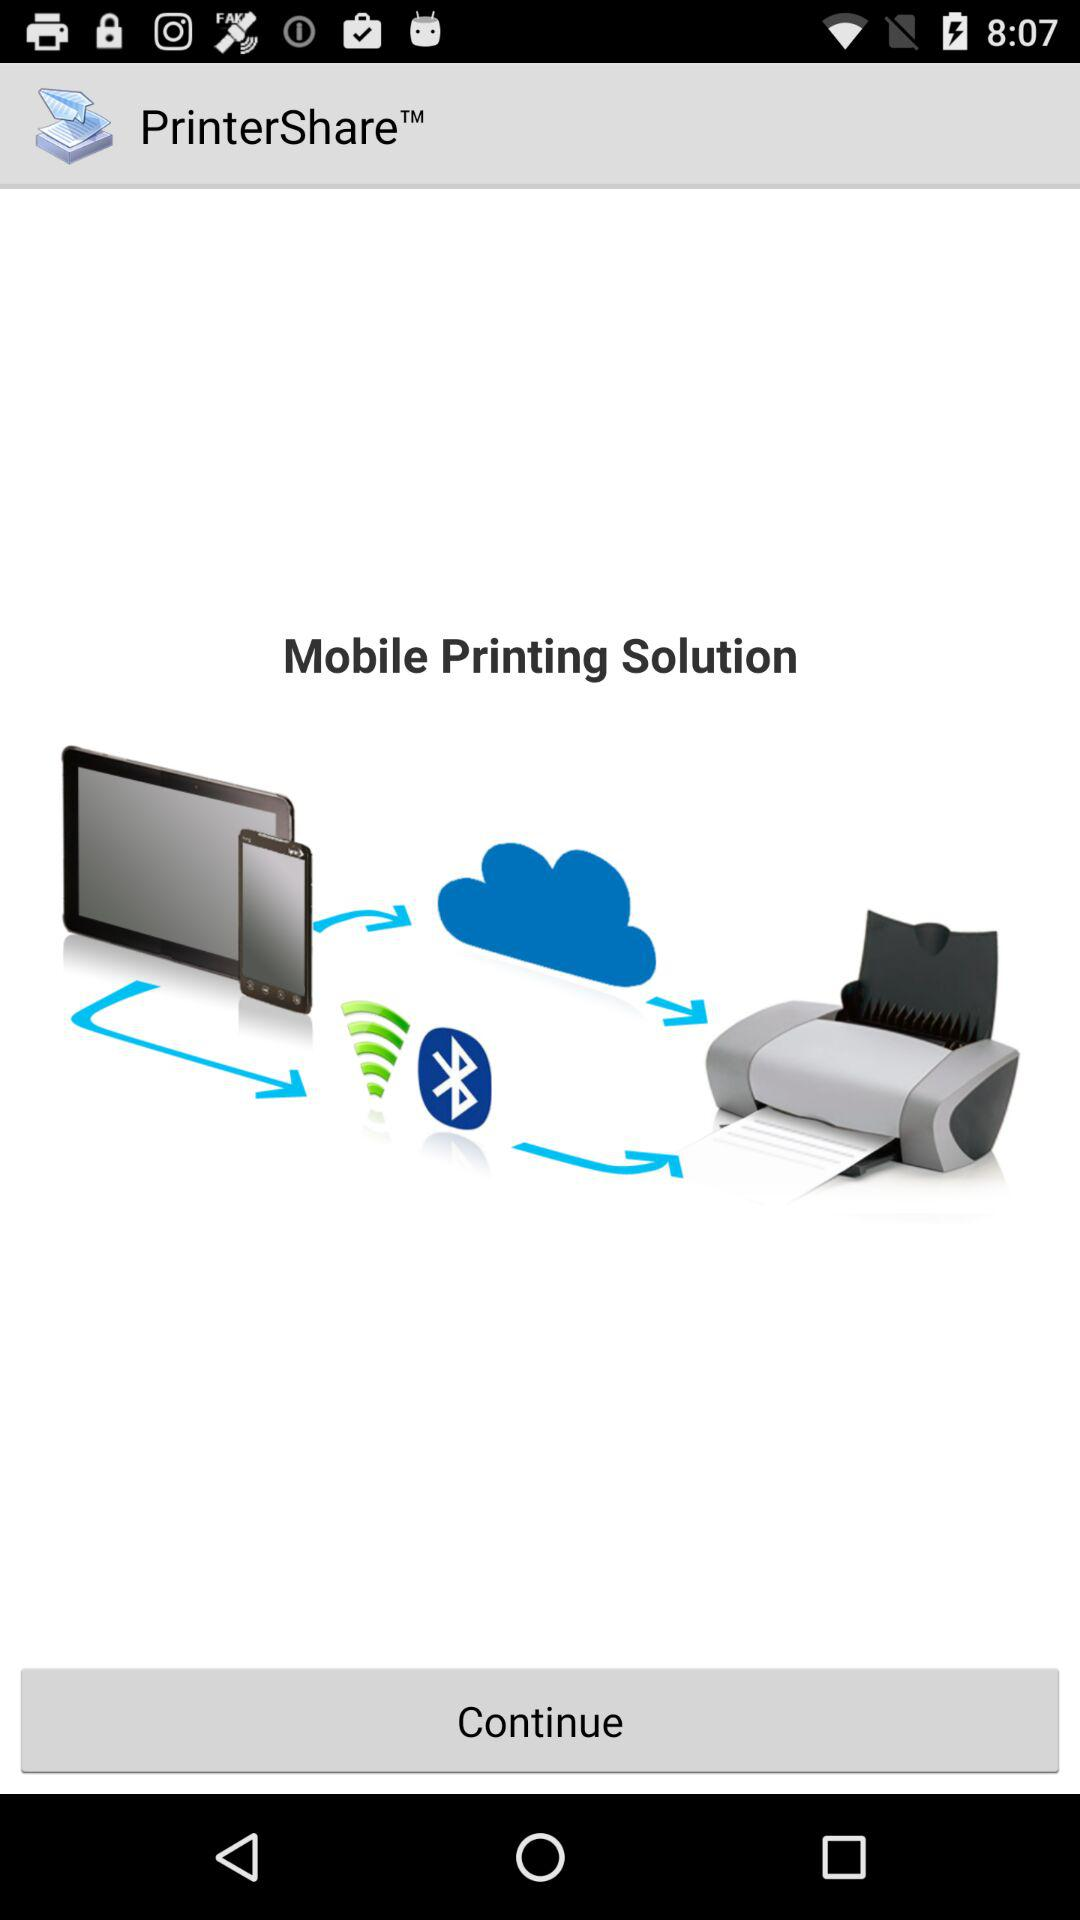What is the app name? The app name is "PrinterShare Mobile Print". 